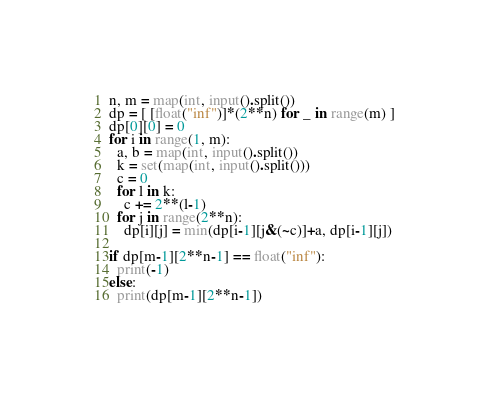Convert code to text. <code><loc_0><loc_0><loc_500><loc_500><_Python_>n, m = map(int, input().split())
dp = [ [float("inf")]*(2**n) for _ in range(m) ]
dp[0][0] = 0
for i in range(1, m):
  a, b = map(int, input().split())
  k = set(map(int, input().split()))
  c = 0
  for l in k:
    c += 2**(l-1)
  for j in range(2**n):
    dp[i][j] = min(dp[i-1][j&(~c)]+a, dp[i-1][j])

if dp[m-1][2**n-1] == float("inf"):
  print(-1)
else:
  print(dp[m-1][2**n-1])</code> 